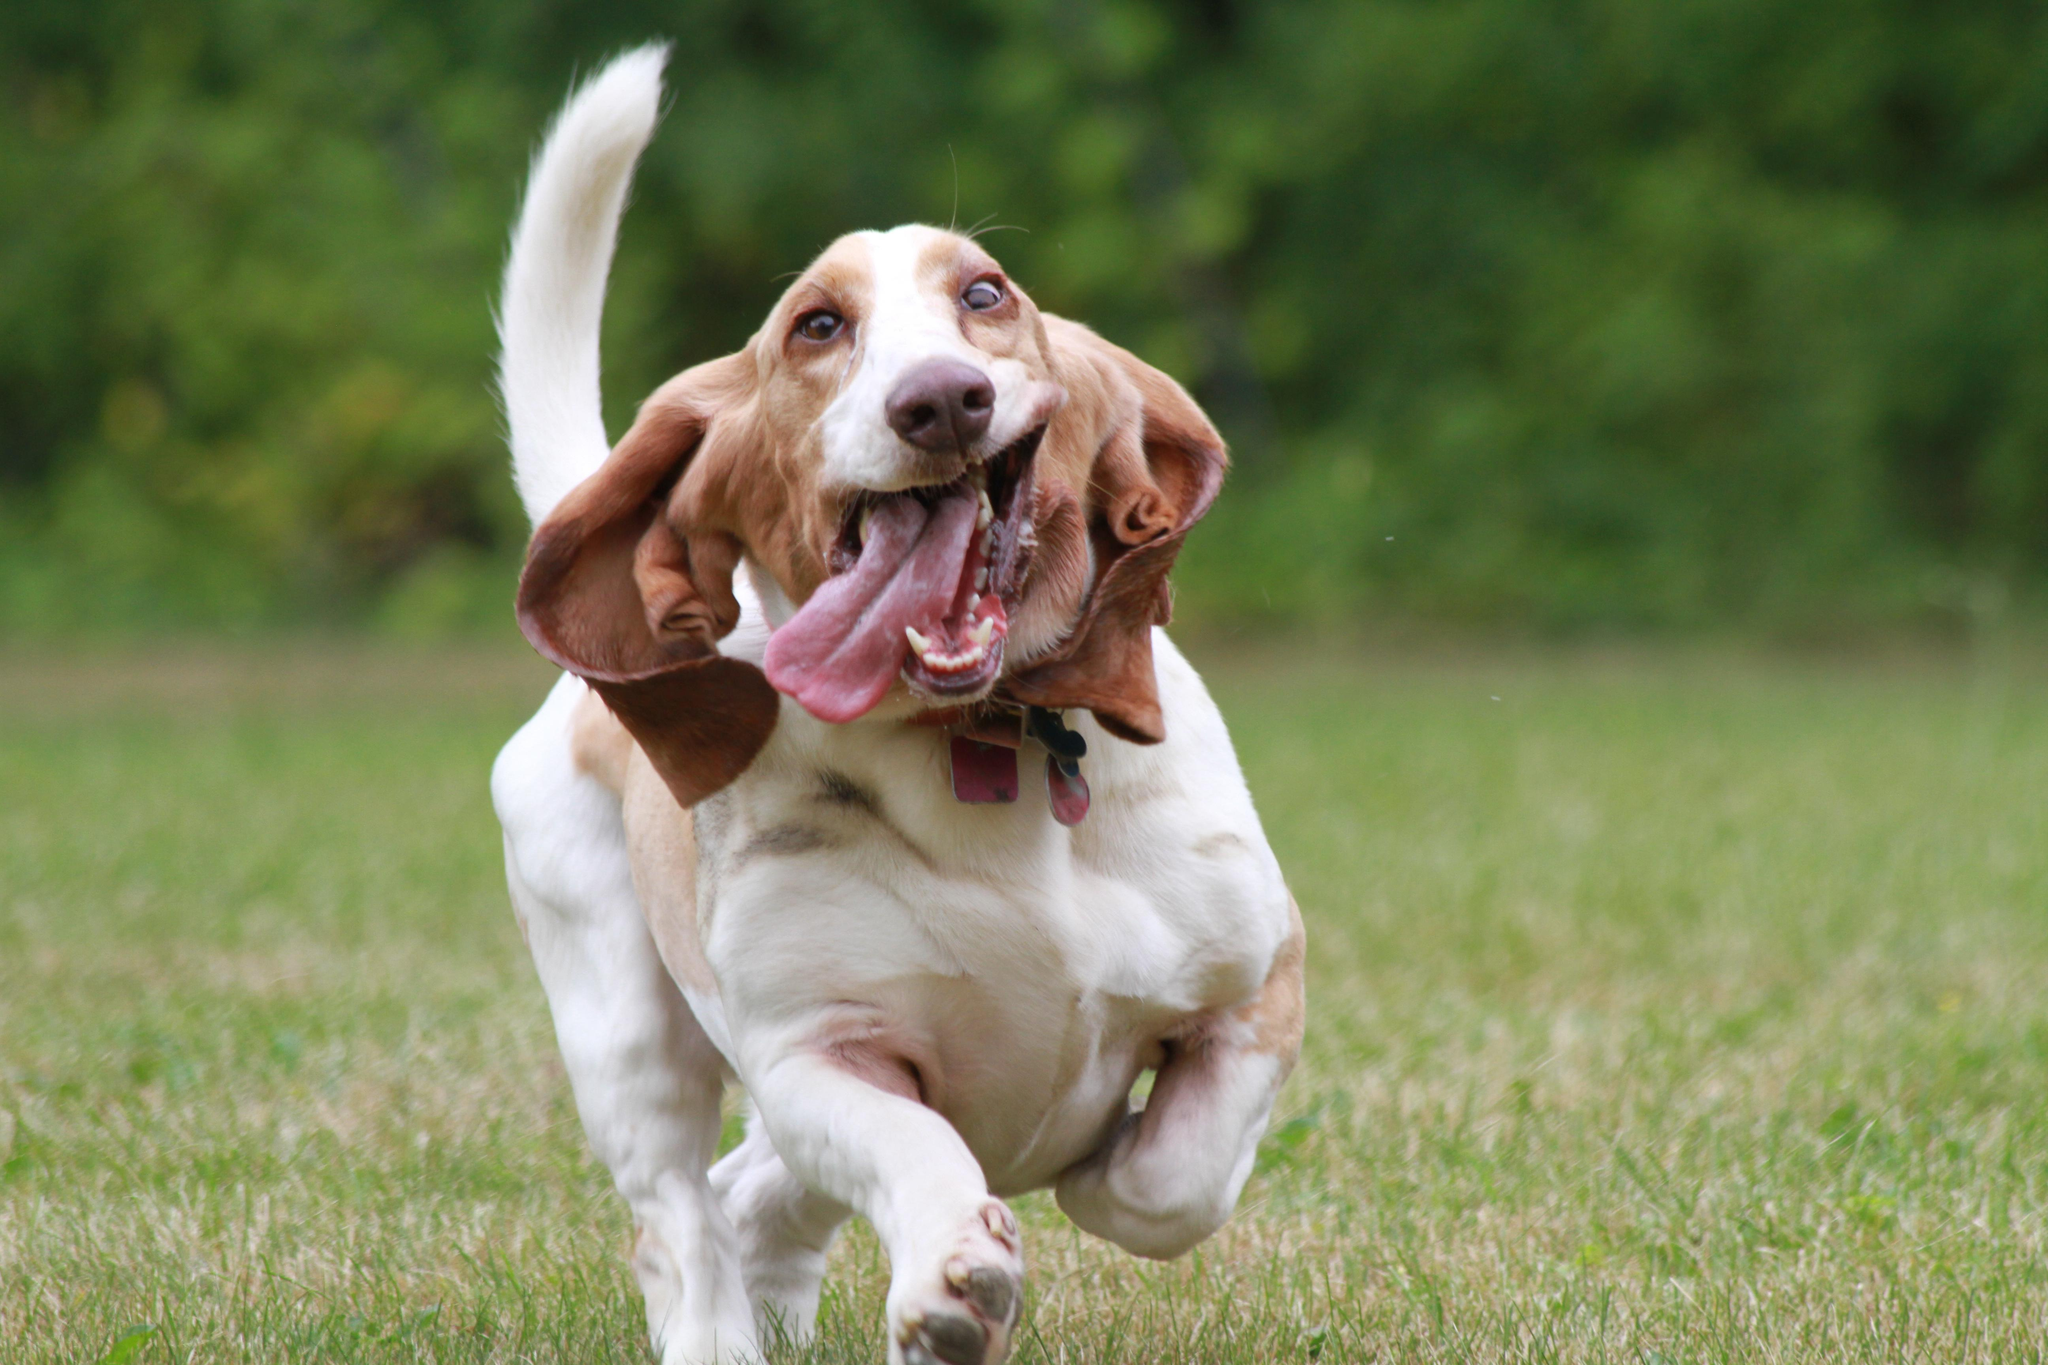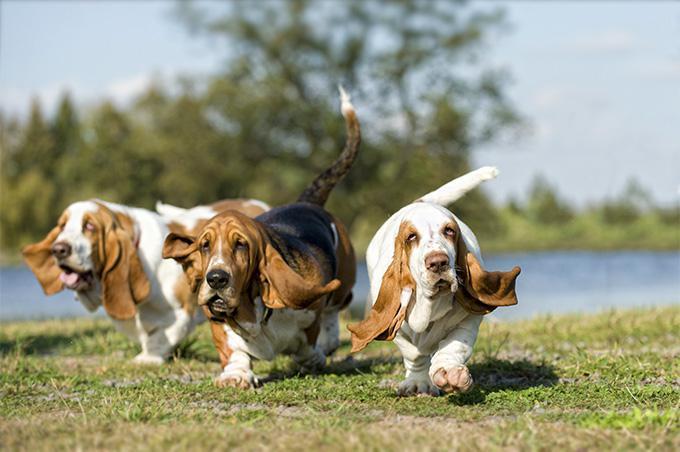The first image is the image on the left, the second image is the image on the right. Assess this claim about the two images: "In one of the images there is a basset hound puppy sitting.". Correct or not? Answer yes or no. No. 